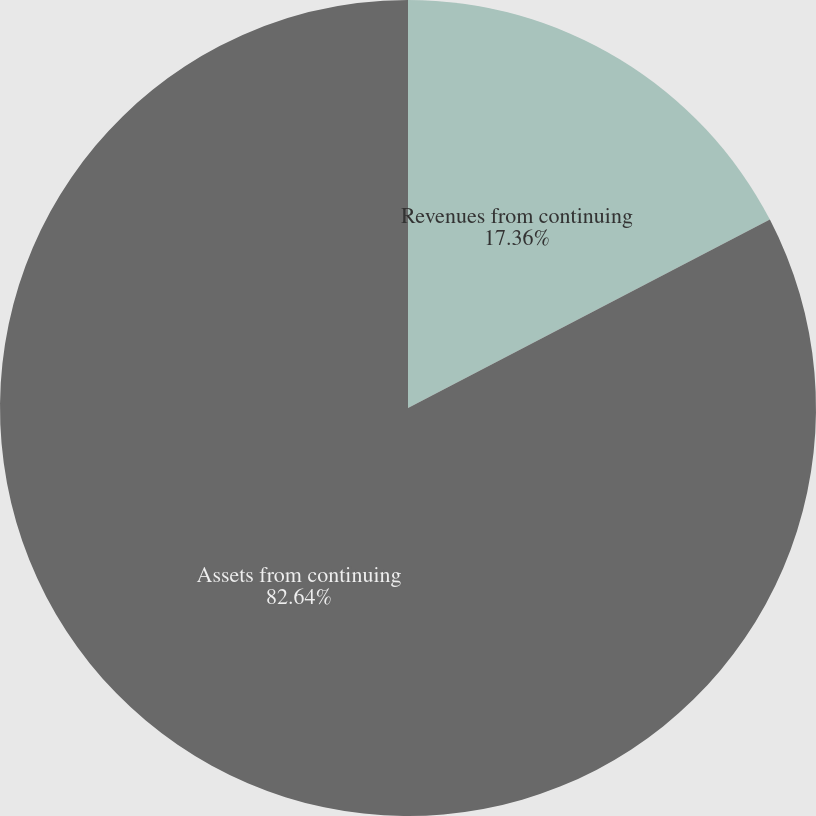Convert chart to OTSL. <chart><loc_0><loc_0><loc_500><loc_500><pie_chart><fcel>Revenues from continuing<fcel>Assets from continuing<nl><fcel>17.36%<fcel>82.64%<nl></chart> 